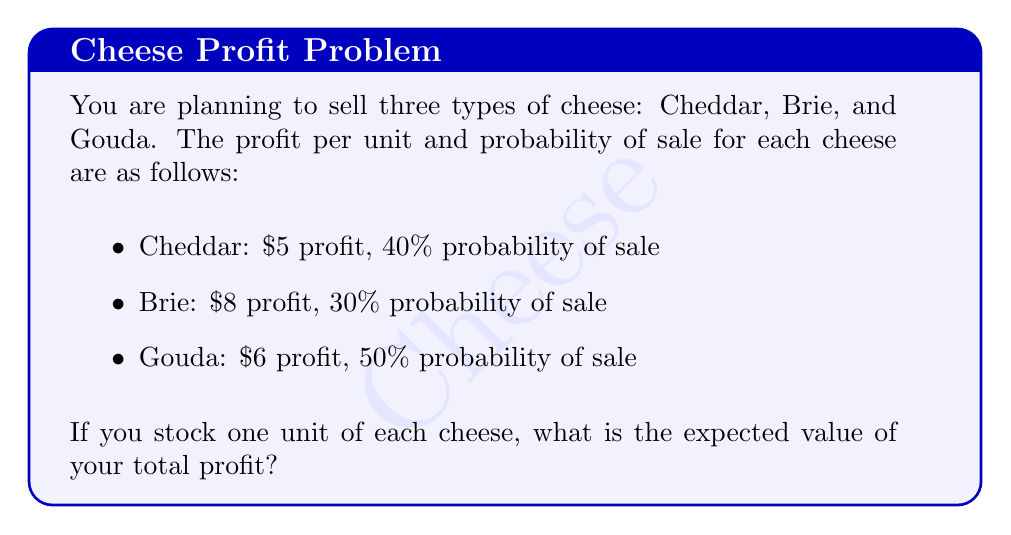Can you answer this question? To calculate the expected value of the total profit, we need to:
1. Calculate the expected value of profit for each cheese
2. Sum up the expected values

Step 1: Calculate the expected value of profit for each cheese
The formula for expected value is:
$$ E(X) = p \times v $$
Where $p$ is the probability and $v$ is the value (profit in this case)

For Cheddar:
$$ E(X_C) = 0.40 \times $5 = $2.00 $$

For Brie:
$$ E(X_B) = 0.30 \times $8 = $2.40 $$

For Gouda:
$$ E(X_G) = 0.50 \times $6 = $3.00 $$

Step 2: Sum up the expected values
The total expected value is the sum of individual expected values:
$$ E(X_{total}) = E(X_C) + E(X_B) + E(X_G) $$
$$ E(X_{total}) = $2.00 + $2.40 + $3.00 = $7.40 $$

Therefore, the expected value of the total profit is $7.40.
Answer: $7.40 